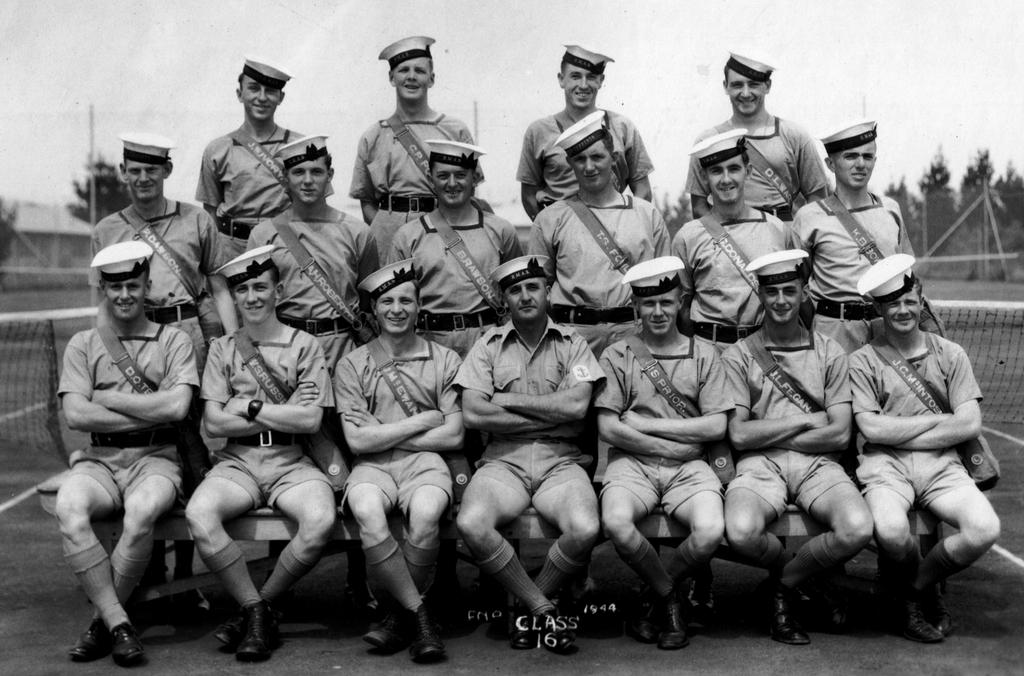What are the people in the image doing? The people in the image are sitting and standing. What are the people wearing on their heads? The people are wearing caps. What can be seen in the background of the image? There are trees and a net in the background of the image. How would you describe the quality of the image? The image is blurred. Is there any text present in the image? Yes, there is text written at the bottom of the image. How many divisions of pigs can be seen in the image? There are no divisions or pigs present in the image. Is there any blood visible in the image? There is no blood visible in the image. 